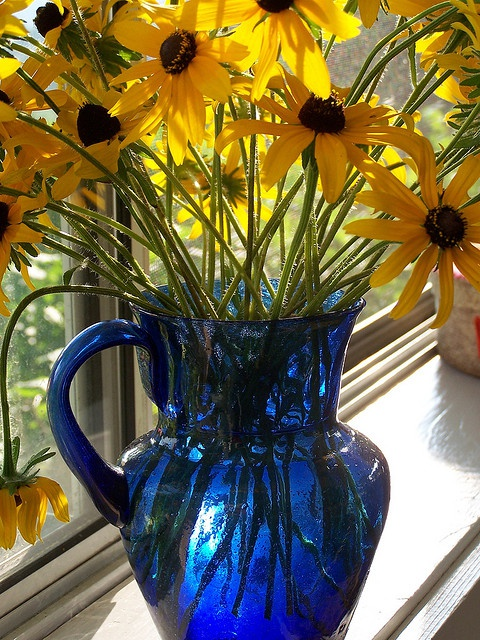Describe the objects in this image and their specific colors. I can see vase in olive, black, navy, gray, and darkblue tones and vase in olive, gray, and brown tones in this image. 